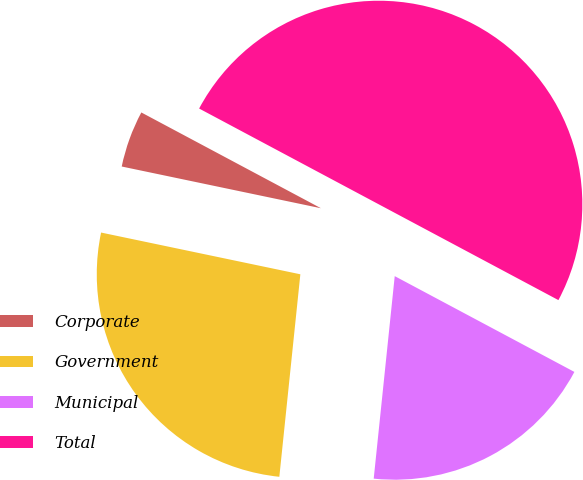Convert chart. <chart><loc_0><loc_0><loc_500><loc_500><pie_chart><fcel>Corporate<fcel>Government<fcel>Municipal<fcel>Total<nl><fcel>4.51%<fcel>26.64%<fcel>18.85%<fcel>50.0%<nl></chart> 